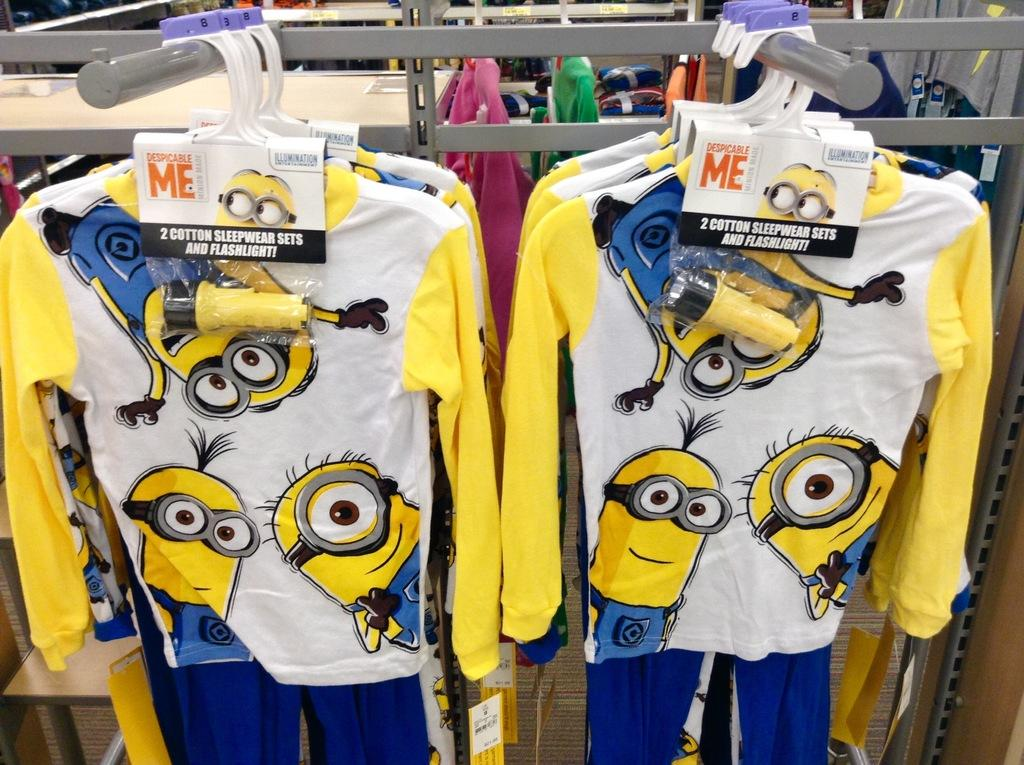<image>
Offer a succinct explanation of the picture presented. Pajamas from the movie Despicable Me come with a flashlight. 